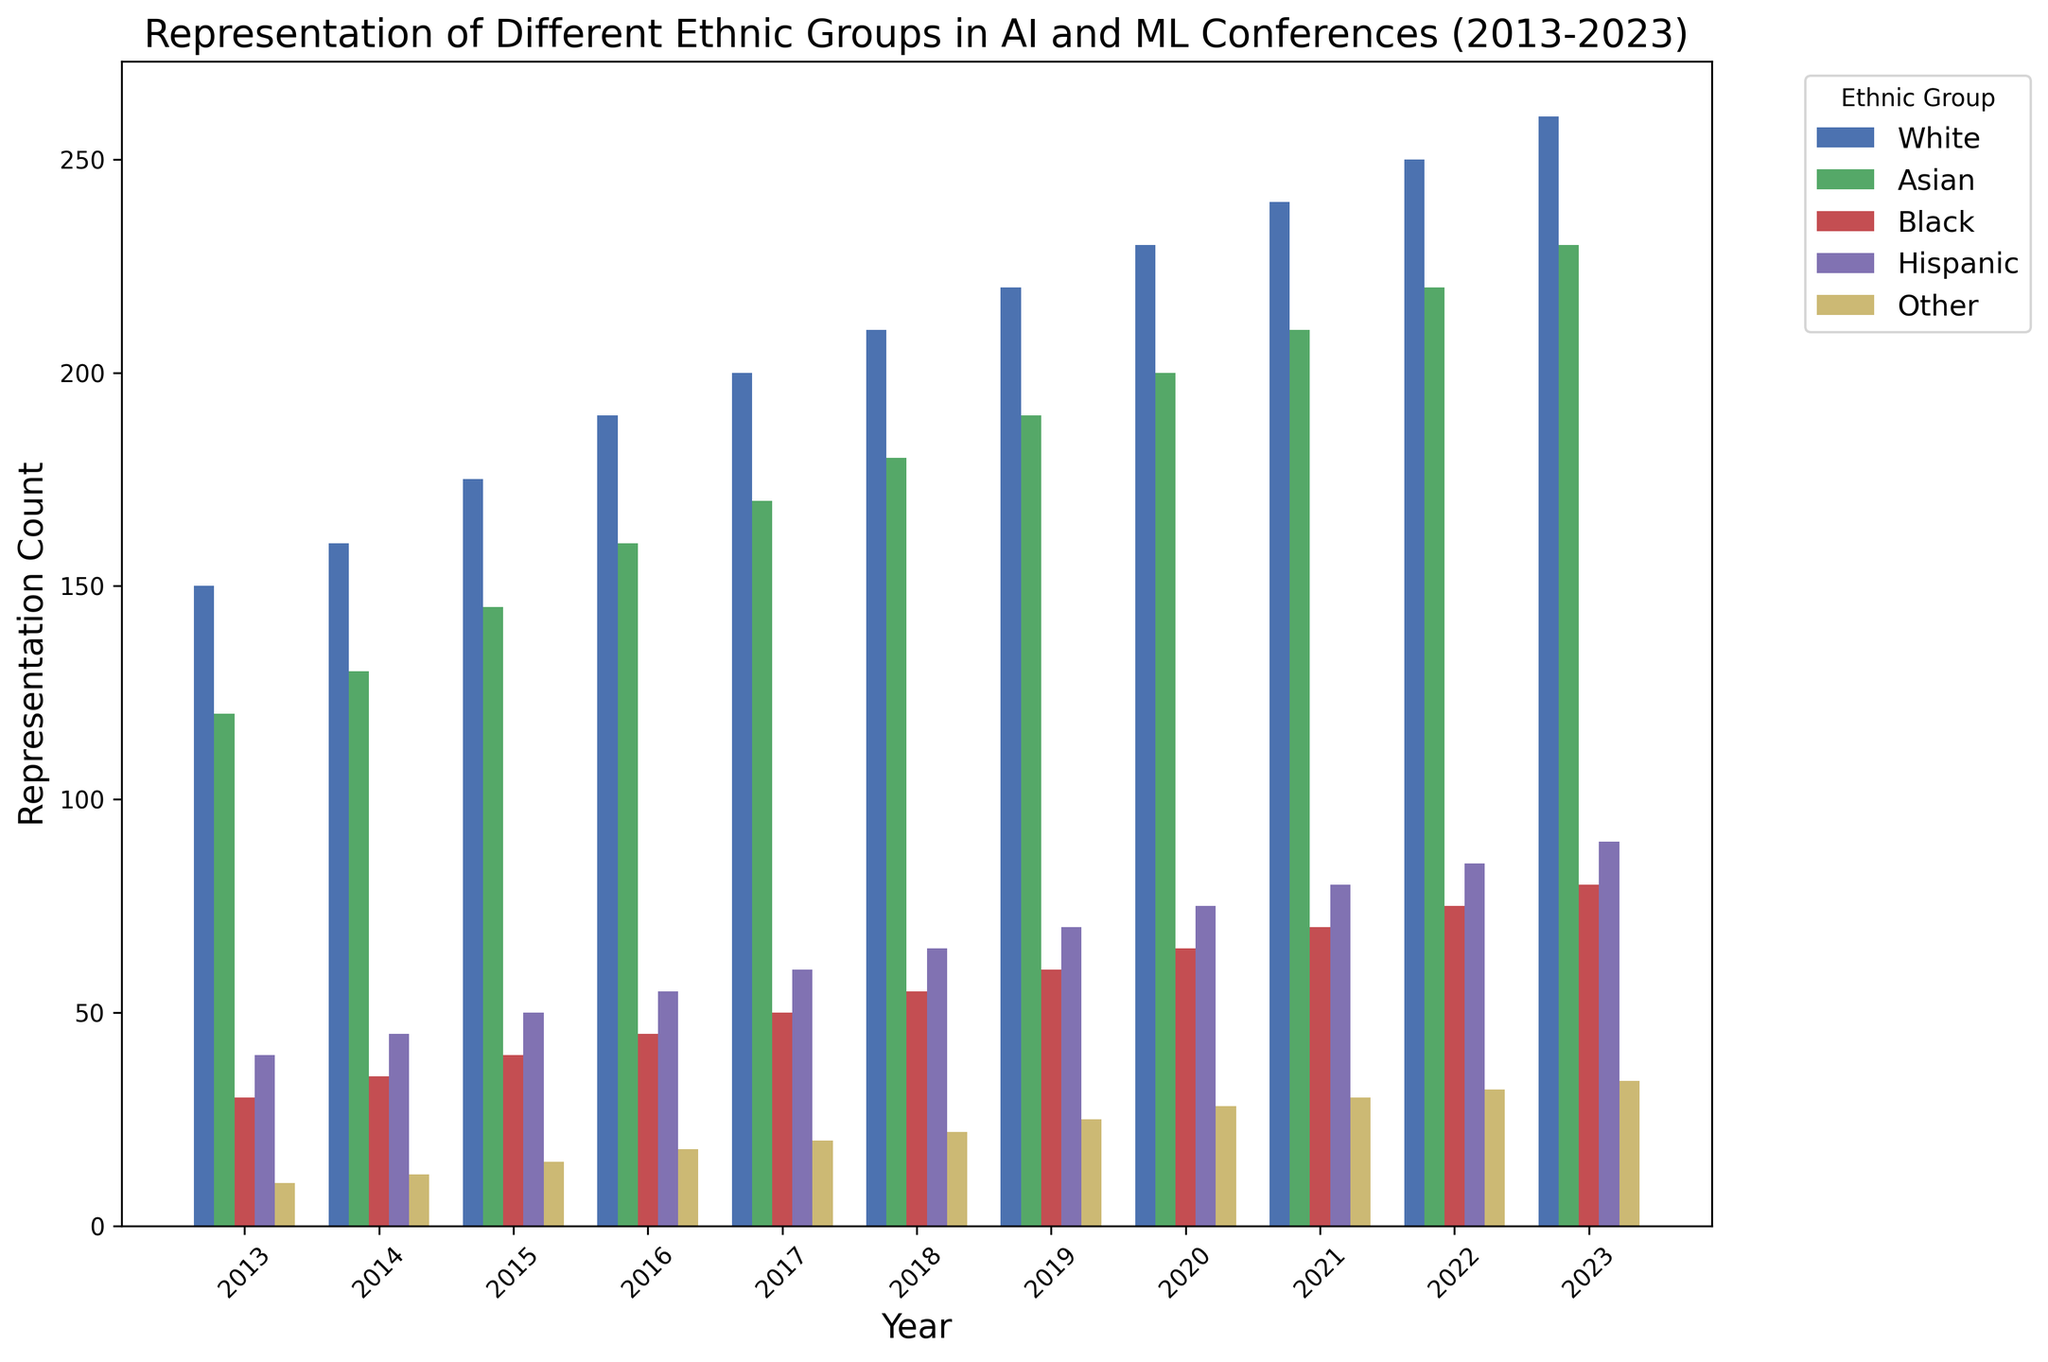What is the difference in representation of White and Asian participants in 2023? To find the difference, look at the height of the bars for White and Asian participants in 2023. The counts are 260 for White and 230 for Asian. Subtract 230 from 260 to get the difference.
Answer: 30 Which ethnic group had the highest representation in 2016? Look at the bars for 2016 and compare their heights. The White group has the tallest bar with a count of 190.
Answer: White What is the total representation of Hispanic participants from 2013 to 2015? Find the counts for Hispanic participants in 2013, 2014, and 2015: 40, 45, and 50, respectively. Sum these values: 40 + 45 + 50 = 135.
Answer: 135 Was there any year where the representation of Black participants was equal to the representation of Other participants? Look at the bars for Black and Other participants in each year. Only in 2021 does the Black bar (count of 70) not match the Other bar (count of 30), hence no years match.
Answer: No Which ethnic group had the lowest representation in 2019? Compare the heights of all bars for 2019. The 'Other' group had the lowest representation with a count of 25.
Answer: Other How did the representation of Asian participants change from 2020 to 2023? Look at the bars for Asian participants in 2020 and 2023. The values are 200 in 2020 and 230 in 2023. The representation increased from 200 to 230.
Answer: Increased What is the average representation of Black participants over the decade? Sum the counts of Black participants from 2013 to 2023: 30 + 35 + 40 + 45 + 50 + 55 + 60 + 65 + 70 + 75 + 80 = 605. Divide by the number of years (11): 605 / 11 = approximately 55.
Answer: 55 How does the height of the Hispanic bar in 2018 compare to the Other bar in the same year? Look at the bars for 2018 for Hispanic and Other groups. The heights are 65 for Hispanic and 22 for Other. The Hispanic bar is clearly taller.
Answer: Taller What is the trend in the representation of Other participants from 2013 to 2023? Look at the progression of bar heights for the Other group from 2013 to 2023. The counts increase gradually from 10 in 2013 to 34 in 2023.
Answer: Increasing trend Which ethnic group showed the most consistent representation growth over the decade? Look at the trend of bars for each ethnic group from 2013 to 2023. The White group's representation consistently increases every year without any drops.
Answer: White 